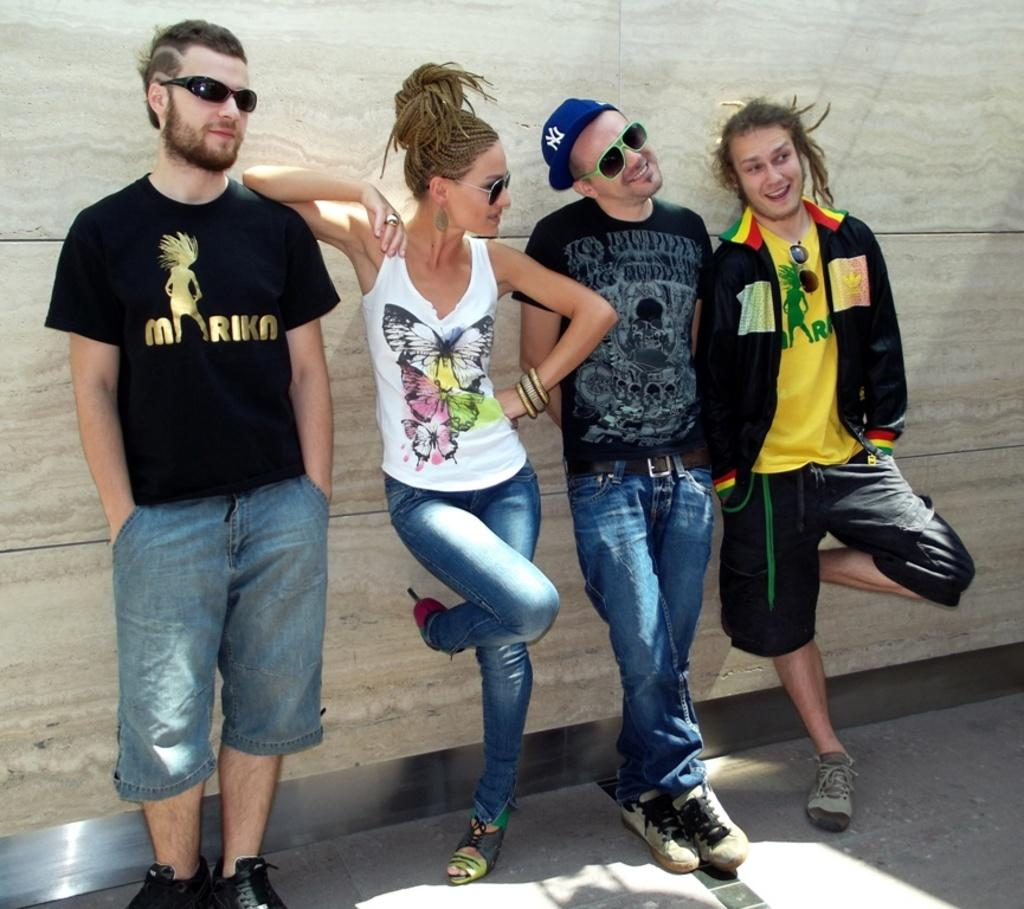How many people are in the image? There are four persons standing in the image. What are the three persons wearing? Three of the persons are wearing goggles. What is the fourth person wearing? One person is wearing a cap. What can be seen in the background of the image? There is a wall in the background of the image. What type of window can be seen in the image? There is no window present in the image; it only features four persons and a wall in the background. What emotion is the person in the cap displaying in the image? The image does not show any emotions or expressions of the persons, so it cannot be determined what emotion the person in the cap might be displaying. 